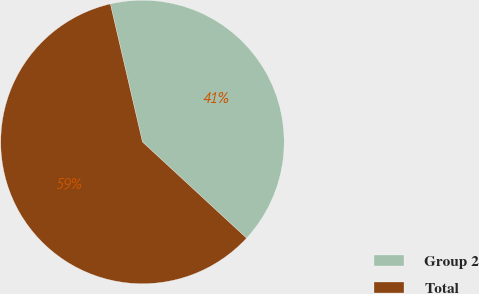Convert chart. <chart><loc_0><loc_0><loc_500><loc_500><pie_chart><fcel>Group 2<fcel>Total<nl><fcel>40.51%<fcel>59.49%<nl></chart> 